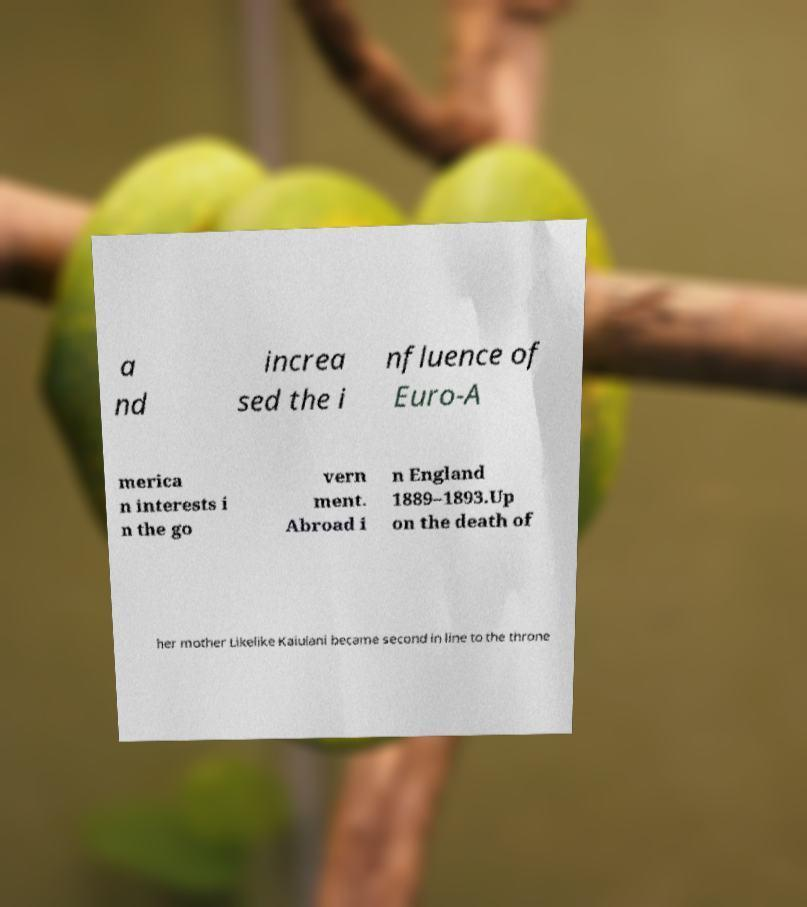Can you accurately transcribe the text from the provided image for me? a nd increa sed the i nfluence of Euro-A merica n interests i n the go vern ment. Abroad i n England 1889–1893.Up on the death of her mother Likelike Kaiulani became second in line to the throne 